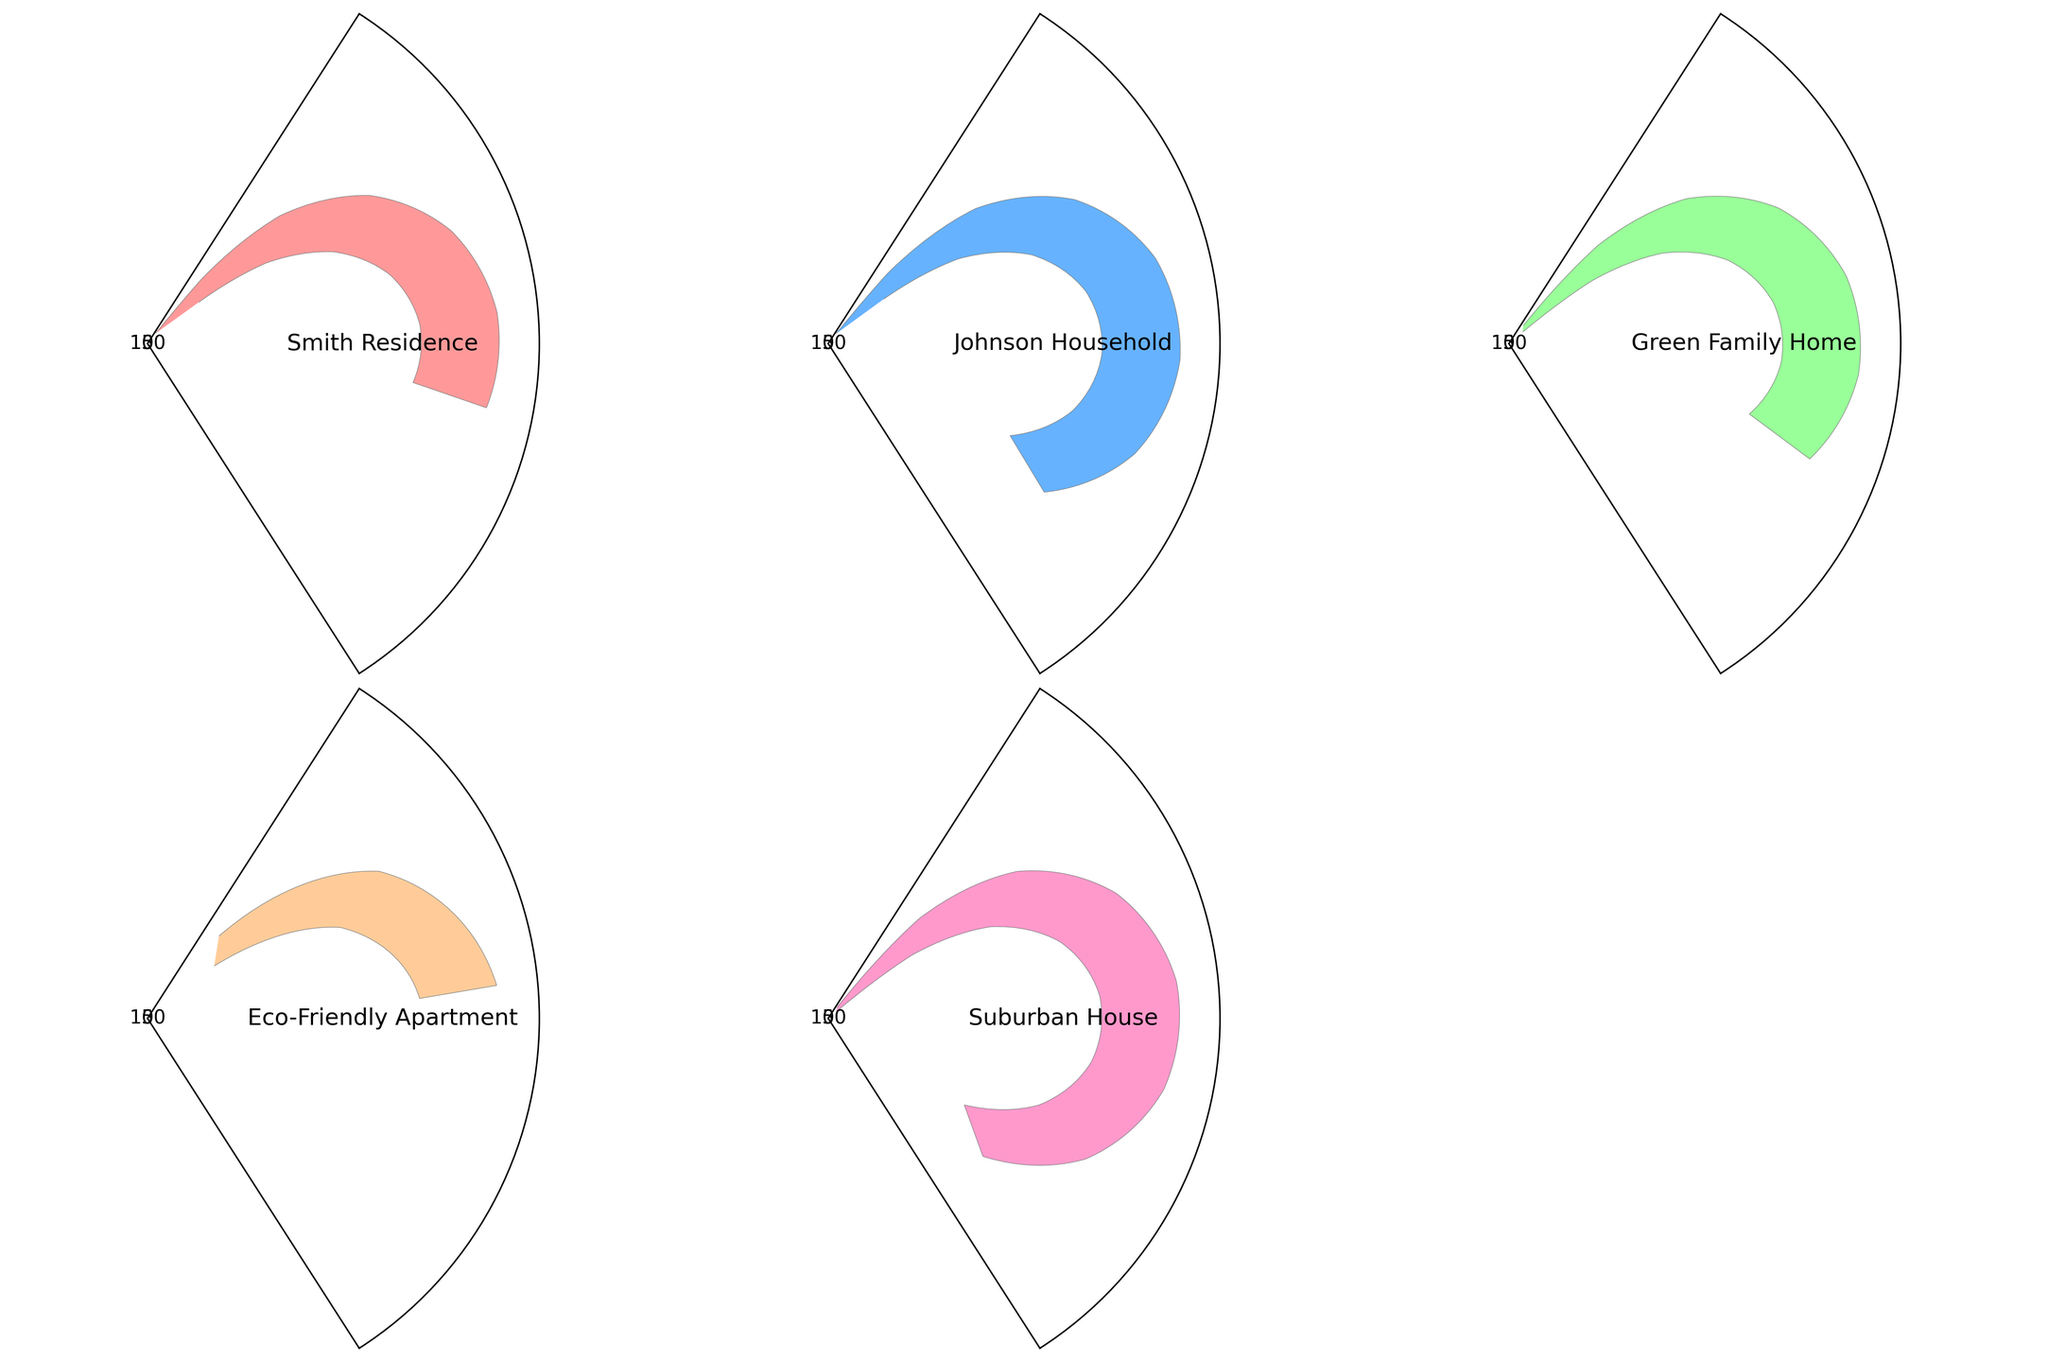How many homes are compared in the figure? There are five gauge charts in the figure, each representing a different home.
Answer: 5 Which home has the highest energy usage? By looking at the gauge charts, the Johnson Household has the highest energy usage, with its gauge tilting the most towards the highest value.
Answer: Johnson Household Which home uses less energy than the local average? The gauge charts for the Smith Residence, Green Family Home, and Eco-Friendly Apartment all show usage values below the marked average line on their respective gauges.
Answer: Smith Residence, Green Family Home, Eco-Friendly Apartment What is the range of energy usage among the homes? The highest usage is 120 (Suburban House) and the lowest is 70 (Eco-Friendly Apartment). The range is calculated as 120 - 70.
Answer: 50 Which homes have the same local average usage value? All homes have the same local average usage value of 100, as seen from the marked average lines in each gauge chart.
Answer: All homes Calculate the difference in energy usage between the Suburban House and the Eco-Friendly Apartment. The Suburban House uses 120 units, while the Eco-Friendly Apartment uses 70 units. The difference is 120 - 70.
Answer: 50 How many homes have energy usage above the local average? By looking at the gauge charts, the Johnson Household and Suburban House both have usage values above the marked average line on their respective gauges.
Answer: 2 Which home has the energy usage closest to the local average? The Green Family Home has an energy usage of 95, which is closest to the local average of 100.
Answer: Green Family Home What is the lowest energy usage value among the homes? The gauge chart for Eco-Friendly Apartment shows the lowest usage value, which is 70.
Answer: 70 Identify the max value indicated on the gauge charts. Each gauge chart has the maximum value marked at 150.
Answer: 150 